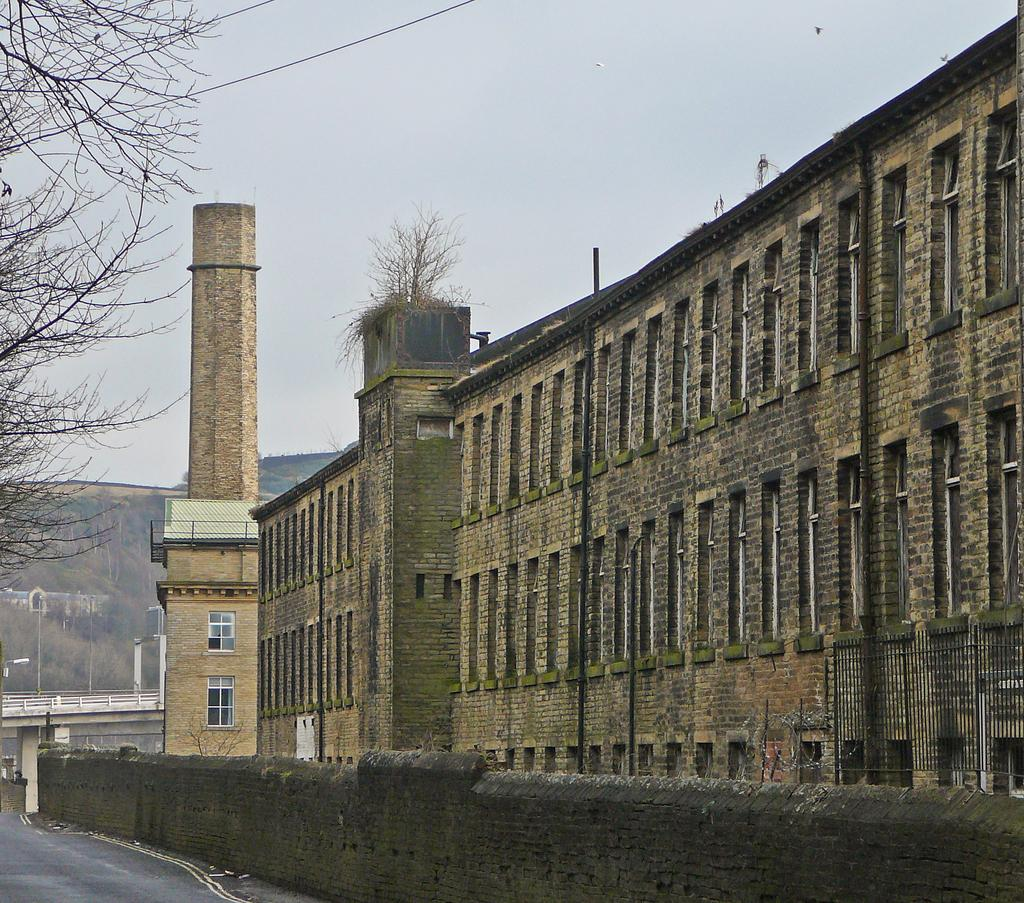What type of structure is present in the image? There is a building in the image. What is located at the bottom of the image? There is a wall at the bottom of the image. What can be seen on the left side of the image? There is a bridge on the left side of the image. What type of natural elements are visible in the background of the image? There are trees in the background of the image. What else can be seen in the background of the image? There are wires and the sky visible in the background of the image. Who is the manager of the wilderness in the image? There is no wilderness or manager present in the image. How does the lift function in the image? There is no lift present in the image. 